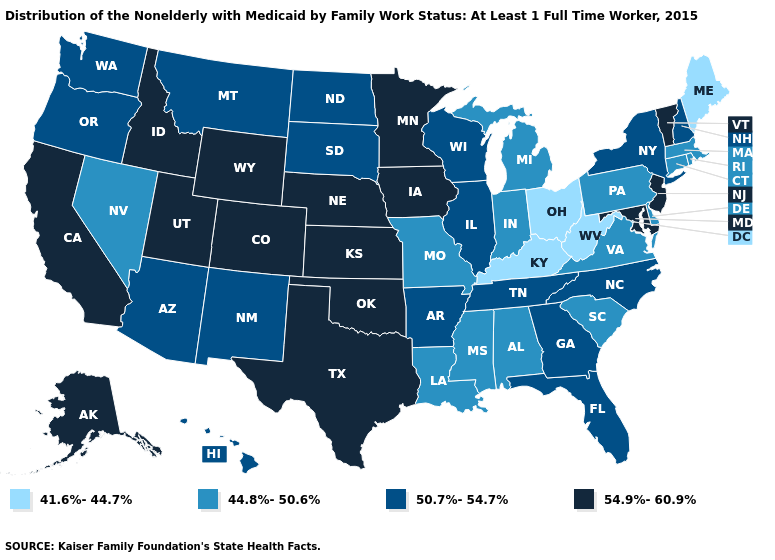What is the value of New Mexico?
Be succinct. 50.7%-54.7%. Among the states that border Utah , does Colorado have the highest value?
Concise answer only. Yes. What is the value of Colorado?
Keep it brief. 54.9%-60.9%. Name the states that have a value in the range 44.8%-50.6%?
Give a very brief answer. Alabama, Connecticut, Delaware, Indiana, Louisiana, Massachusetts, Michigan, Mississippi, Missouri, Nevada, Pennsylvania, Rhode Island, South Carolina, Virginia. What is the highest value in the West ?
Quick response, please. 54.9%-60.9%. Name the states that have a value in the range 44.8%-50.6%?
Keep it brief. Alabama, Connecticut, Delaware, Indiana, Louisiana, Massachusetts, Michigan, Mississippi, Missouri, Nevada, Pennsylvania, Rhode Island, South Carolina, Virginia. What is the value of Wisconsin?
Short answer required. 50.7%-54.7%. Name the states that have a value in the range 44.8%-50.6%?
Write a very short answer. Alabama, Connecticut, Delaware, Indiana, Louisiana, Massachusetts, Michigan, Mississippi, Missouri, Nevada, Pennsylvania, Rhode Island, South Carolina, Virginia. Name the states that have a value in the range 54.9%-60.9%?
Quick response, please. Alaska, California, Colorado, Idaho, Iowa, Kansas, Maryland, Minnesota, Nebraska, New Jersey, Oklahoma, Texas, Utah, Vermont, Wyoming. Among the states that border South Dakota , which have the highest value?
Write a very short answer. Iowa, Minnesota, Nebraska, Wyoming. What is the highest value in the MidWest ?
Keep it brief. 54.9%-60.9%. Does Missouri have the same value as Louisiana?
Concise answer only. Yes. Which states have the highest value in the USA?
Answer briefly. Alaska, California, Colorado, Idaho, Iowa, Kansas, Maryland, Minnesota, Nebraska, New Jersey, Oklahoma, Texas, Utah, Vermont, Wyoming. What is the value of Alaska?
Short answer required. 54.9%-60.9%. What is the highest value in the USA?
Be succinct. 54.9%-60.9%. 